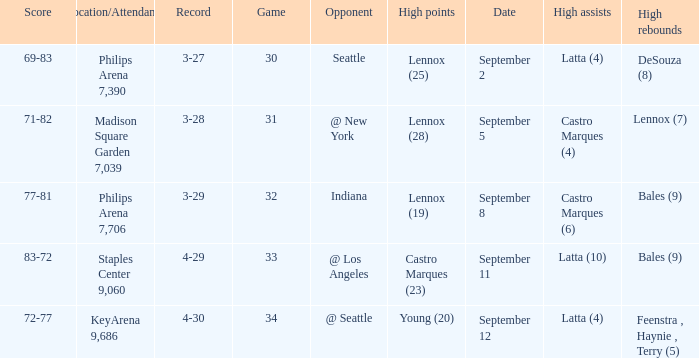Which Location/Attendance has High rebounds of lennox (7)? Madison Square Garden 7,039. 